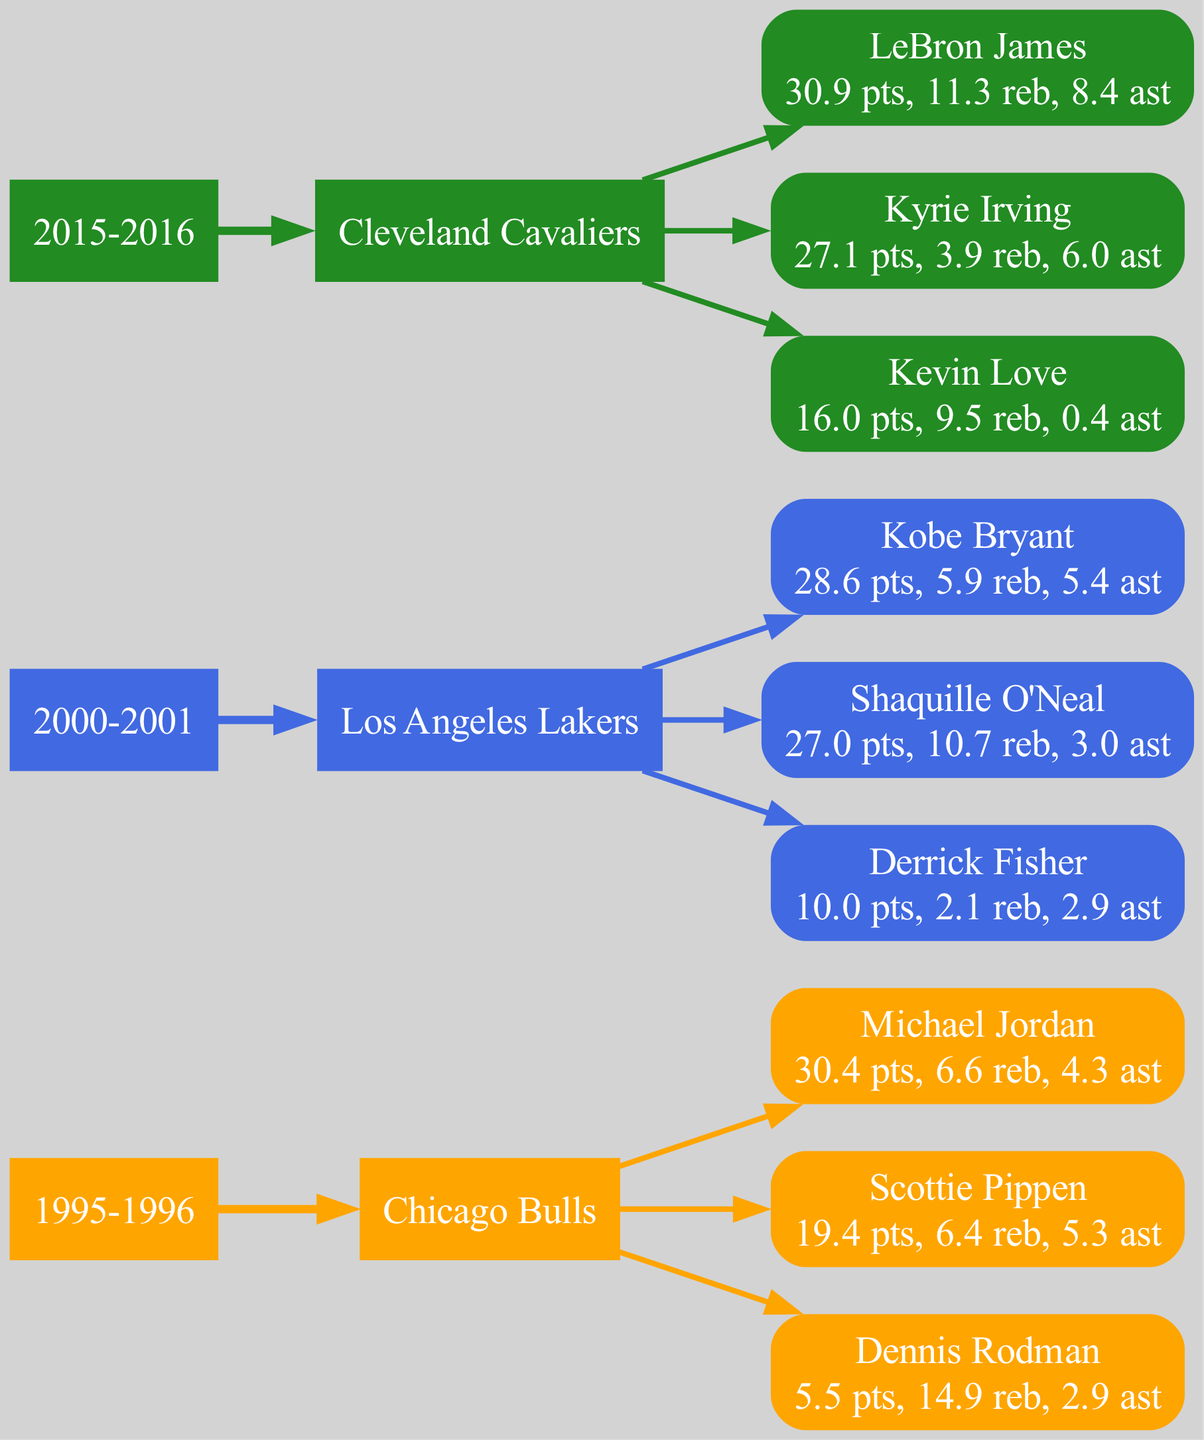What season did the Chicago Bulls win a championship? The diagram shows that the Chicago Bulls won a championship in the 1995-1996 season as represented by the corresponding season node.
Answer: 1995-1996 How many key players contributed to the Los Angeles Lakers' championship in 2000-2001? By counting the nodes connected to the Los Angeles Lakers championship node for the 2000-2001 season, we find there are three key player nodes connected to this node.
Answer: 3 What was Michael Jordan's points average during the 1995-1996 season? Looking at Michael Jordan’s node under the Chicago Bulls championship for the 1995-1996 season, it displays that he averaged 30.4 points.
Answer: 30.4 Which player had the highest average rebounds in the 2015-2016 championship team? In the diagram, we examine the player nodes under the Cleveland Cavaliers 2015-2016 championship. We observe that LeBron James had the highest rebounds at 11.3, compared to his teammates.
Answer: LeBron James For which team did Shaquille O'Neal contribute in the 2000-2001 season? The edge connecting Shaquille O'Neal’s node directly shows that he contributed to the Los Angeles Lakers championship in the 2000-2001 season.
Answer: Los Angeles Lakers Which player had the lowest points average in the 1995-1996 Chicago Bulls team? By reviewing the points scored by each key player under the Chicago Bulls node in the 1995-1996 season, we see that Dennis Rodman scored the least with 5.5 points.
Answer: Dennis Rodman What is the total number of championship seasons represented in the diagram? The diagram displays three different seasons dedicated to championship wins, as shown by the season nodes.
Answer: 3 Which team won a championship in 2015-2016? The node labeled '2015-2016' in the season section connects to the Cavaliers' team node, indicating that the Cavaliers won the championship during that season.
Answer: Cleveland Cavaliers Which player had the highest assists average in the 2000-2001 season? We analyze the assists displayed for each player under the Los Angeles Lakers championship node, confirming that Kobe Bryant had the most assists with 5.4 average assists.
Answer: Kobe Bryant 